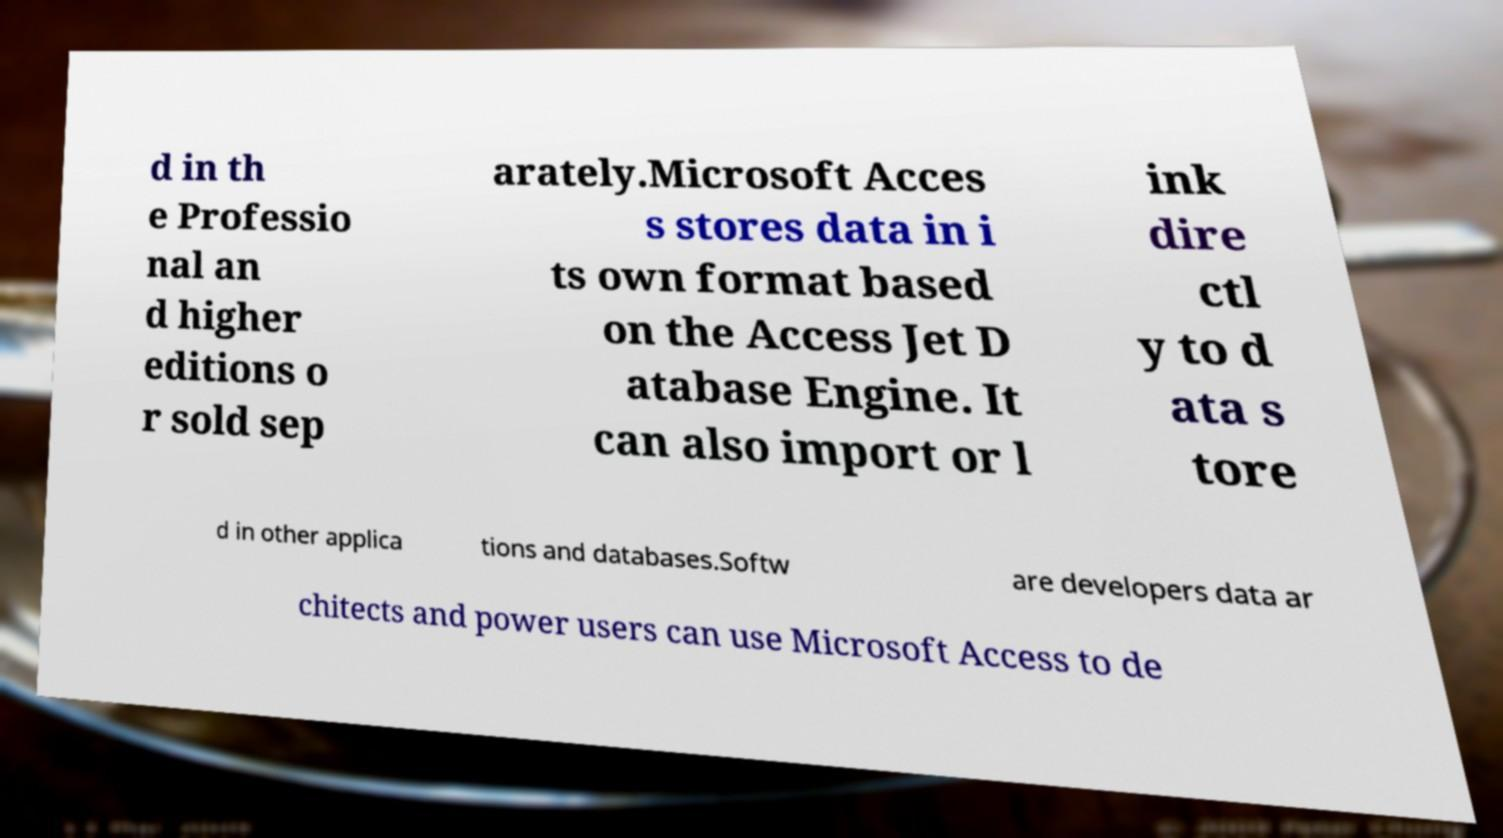Could you assist in decoding the text presented in this image and type it out clearly? d in th e Professio nal an d higher editions o r sold sep arately.Microsoft Acces s stores data in i ts own format based on the Access Jet D atabase Engine. It can also import or l ink dire ctl y to d ata s tore d in other applica tions and databases.Softw are developers data ar chitects and power users can use Microsoft Access to de 